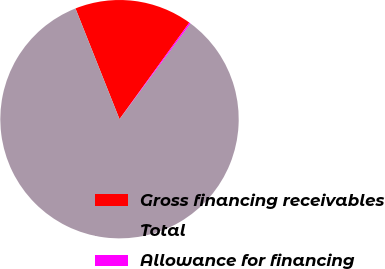<chart> <loc_0><loc_0><loc_500><loc_500><pie_chart><fcel>Gross financing receivables<fcel>Total<fcel>Allowance for financing<nl><fcel>15.99%<fcel>83.82%<fcel>0.19%<nl></chart> 